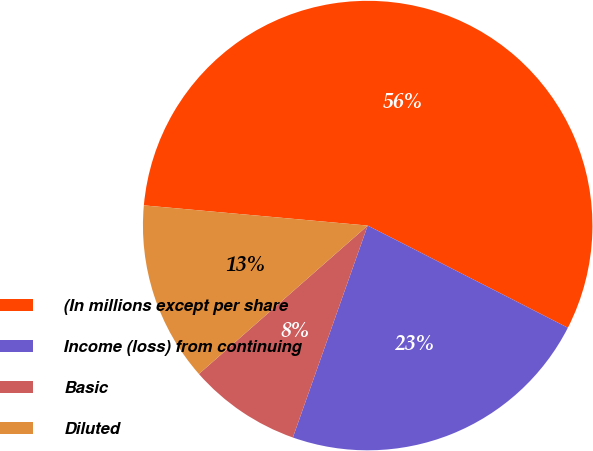Convert chart to OTSL. <chart><loc_0><loc_0><loc_500><loc_500><pie_chart><fcel>(In millions except per share<fcel>Income (loss) from continuing<fcel>Basic<fcel>Diluted<nl><fcel>56.08%<fcel>22.89%<fcel>8.12%<fcel>12.91%<nl></chart> 